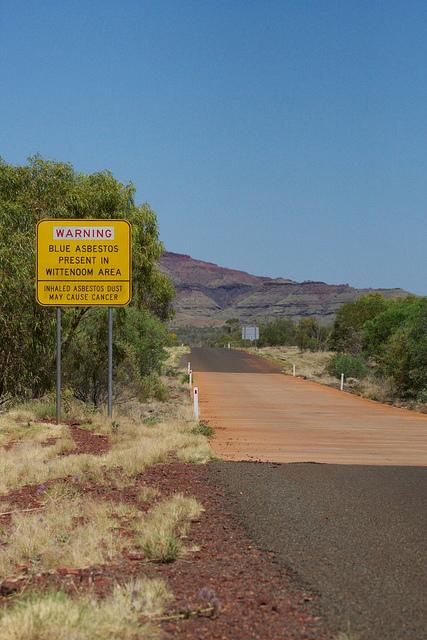What color is the question written in?
Quick response, please. Black. Are there any people about?
Short answer required. No. What word is on the top of the sign?
Concise answer only. Warning. What is written on the sign?
Answer briefly. Warning. What is the color of the weeds and grass?
Quick response, please. Green. What does the sign say?
Short answer required. Warning. What color is the road?
Answer briefly. Brown. Is the area flat?
Quick response, please. No. What color is the sign pictured?
Give a very brief answer. Yellow. 